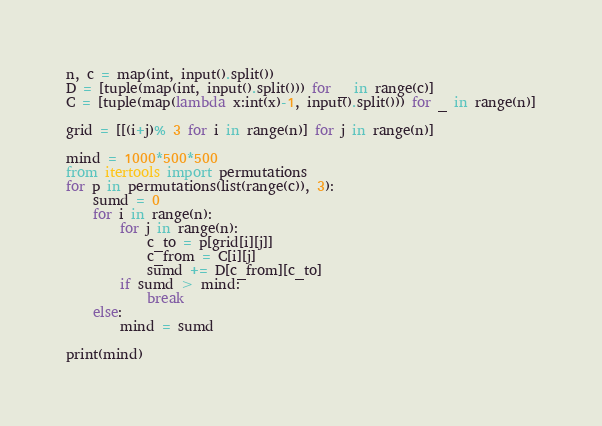<code> <loc_0><loc_0><loc_500><loc_500><_Python_>n, c = map(int, input().split())
D = [tuple(map(int, input().split())) for _ in range(c)]
C = [tuple(map(lambda x:int(x)-1, input().split())) for _ in range(n)]

grid = [[(i+j)% 3 for i in range(n)] for j in range(n)]

mind = 1000*500*500
from itertools import permutations
for p in permutations(list(range(c)), 3):
    sumd = 0
    for i in range(n):
        for j in range(n):
            c_to = p[grid[i][j]]
            c_from = C[i][j]
            sumd += D[c_from][c_to]
        if sumd > mind:
            break
    else:
        mind = sumd

print(mind)
</code> 